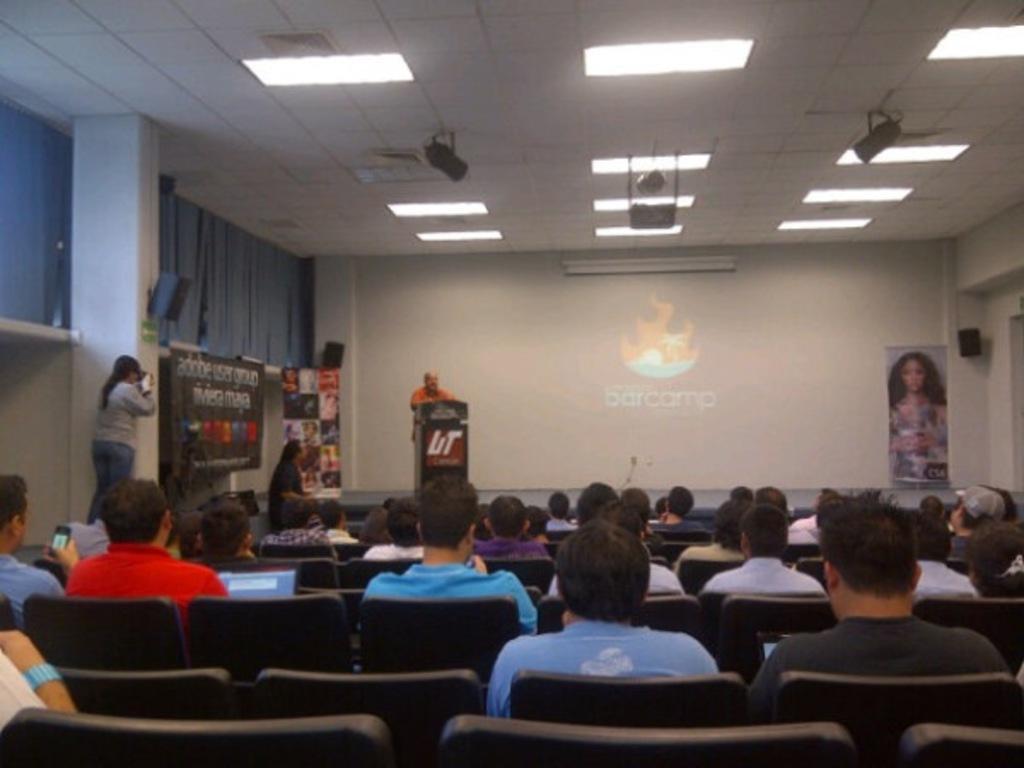Describe this image in one or two sentences. In this image I can see a group of people are sitting on the chairs. In the middle there is a man standing, near the podium, there is the projector screen. At the top there are ceiling lights, it looks like an auditorium. 